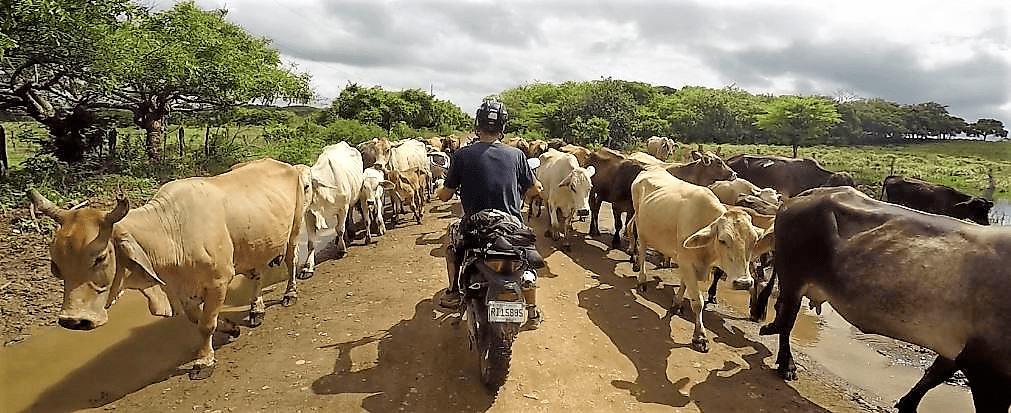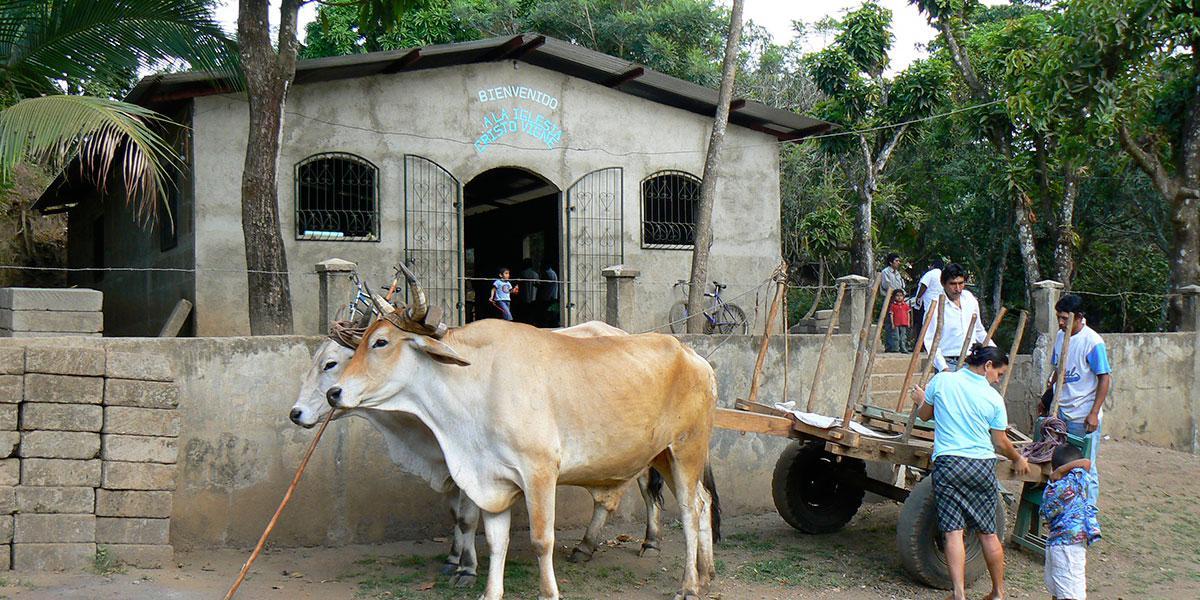The first image is the image on the left, the second image is the image on the right. Examine the images to the left and right. Is the description "All of the animals are walking." accurate? Answer yes or no. No. The first image is the image on the left, the second image is the image on the right. Evaluate the accuracy of this statement regarding the images: "All the cows in the image are attached to, and pulling, something behind them.". Is it true? Answer yes or no. No. 